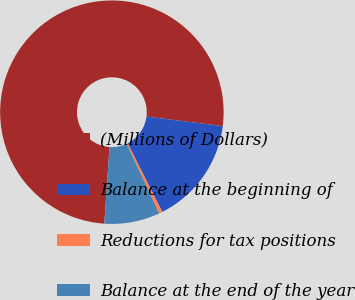<chart> <loc_0><loc_0><loc_500><loc_500><pie_chart><fcel>(Millions of Dollars)<fcel>Balance at the beginning of<fcel>Reductions for tax positions<fcel>Balance at the end of the year<nl><fcel>75.9%<fcel>15.57%<fcel>0.49%<fcel>8.03%<nl></chart> 